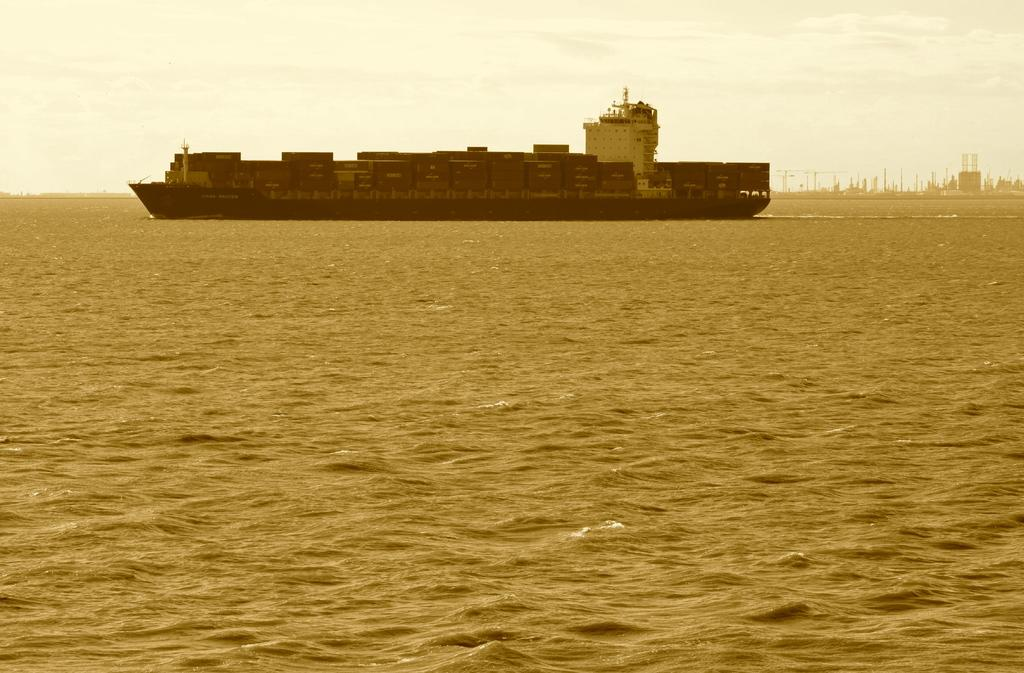What is the main subject of the image? There is a ship on the water in the image. What can be seen in the background of the image? There are buildings in the background of the image. What is visible in the sky in the image? There are clouds in the sky in the image. What time does the clock show in the image? There is no clock present in the image. Can you describe the girl standing next to the ship in the image? There is no girl present in the image; it only features a ship on the water, buildings in the background, and clouds in the sky. 